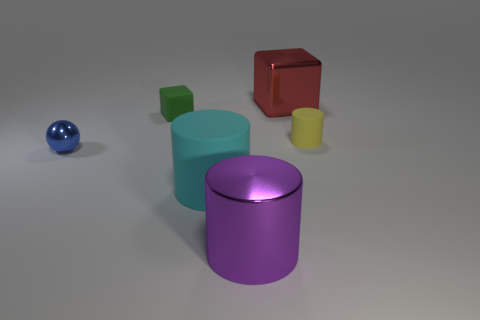Is there a red object of the same shape as the green object?
Ensure brevity in your answer.  Yes. There is a blue thing that is the same size as the yellow rubber thing; what is its shape?
Ensure brevity in your answer.  Sphere. What material is the red block?
Give a very brief answer. Metal. There is a cylinder that is in front of the rubber cylinder in front of the thing that is to the right of the large red object; how big is it?
Give a very brief answer. Large. How many rubber objects are either red objects or green cylinders?
Your response must be concise. 0. What is the size of the shiny block?
Offer a very short reply. Large. What number of things are either large cylinders or objects that are in front of the tiny blue sphere?
Your answer should be very brief. 2. What number of other objects are there of the same color as the small matte cylinder?
Offer a terse response. 0. There is a matte cube; does it have the same size as the metal thing that is to the left of the big purple thing?
Make the answer very short. Yes. Is the size of the blue metallic thing that is behind the purple metal thing the same as the cyan cylinder?
Keep it short and to the point. No. 